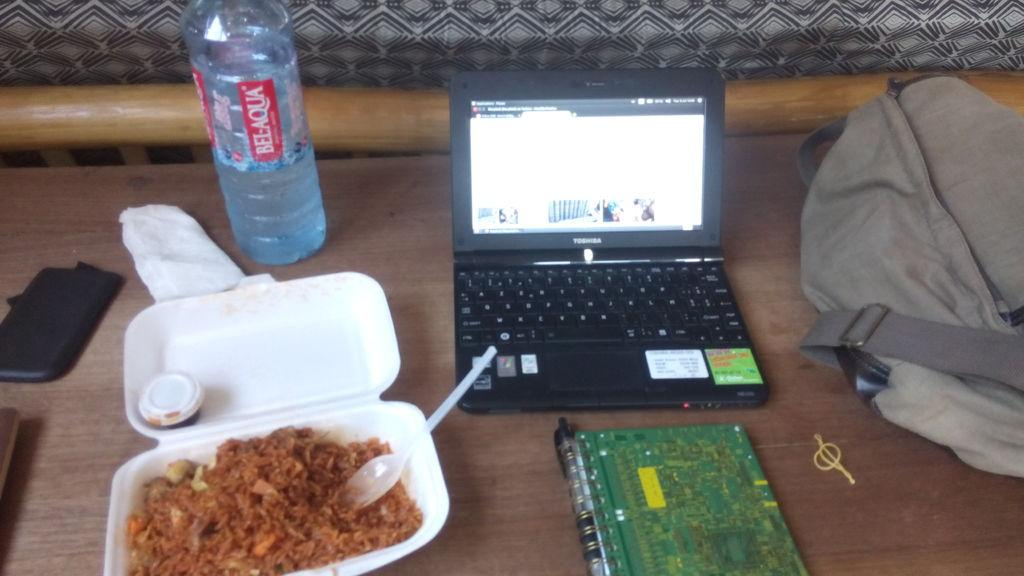Provide a one-sentence caption for the provided image. A bottle of Bel-Aqua is placed above a container of food. 